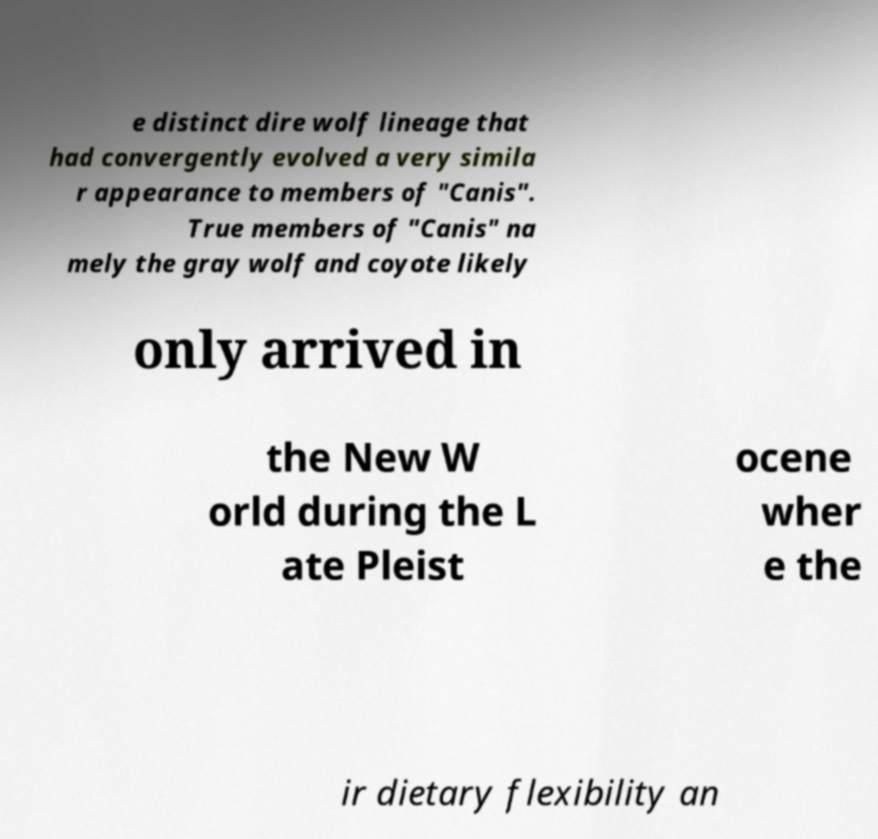For documentation purposes, I need the text within this image transcribed. Could you provide that? e distinct dire wolf lineage that had convergently evolved a very simila r appearance to members of "Canis". True members of "Canis" na mely the gray wolf and coyote likely only arrived in the New W orld during the L ate Pleist ocene wher e the ir dietary flexibility an 